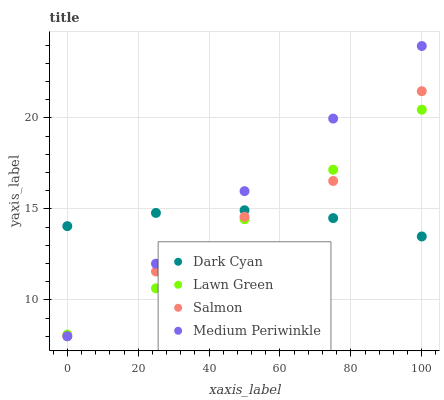Does Lawn Green have the minimum area under the curve?
Answer yes or no. Yes. Does Medium Periwinkle have the maximum area under the curve?
Answer yes or no. Yes. Does Salmon have the minimum area under the curve?
Answer yes or no. No. Does Salmon have the maximum area under the curve?
Answer yes or no. No. Is Medium Periwinkle the smoothest?
Answer yes or no. Yes. Is Salmon the roughest?
Answer yes or no. Yes. Is Lawn Green the smoothest?
Answer yes or no. No. Is Lawn Green the roughest?
Answer yes or no. No. Does Salmon have the lowest value?
Answer yes or no. Yes. Does Lawn Green have the lowest value?
Answer yes or no. No. Does Medium Periwinkle have the highest value?
Answer yes or no. Yes. Does Lawn Green have the highest value?
Answer yes or no. No. Does Dark Cyan intersect Lawn Green?
Answer yes or no. Yes. Is Dark Cyan less than Lawn Green?
Answer yes or no. No. Is Dark Cyan greater than Lawn Green?
Answer yes or no. No. 